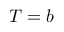<formula> <loc_0><loc_0><loc_500><loc_500>T = b</formula> 